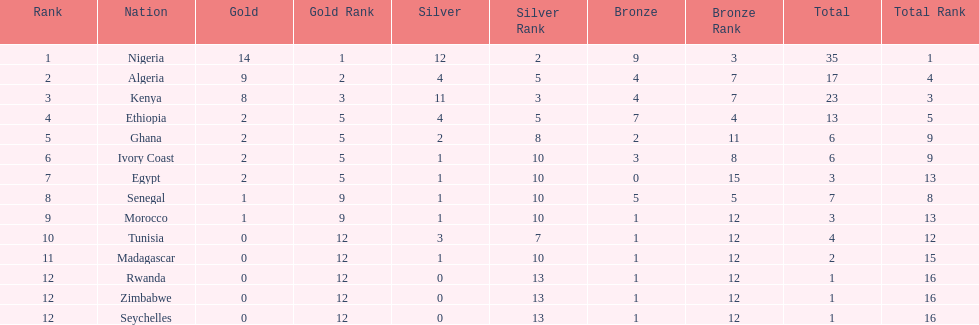Which country had the least bronze medals? Egypt. 